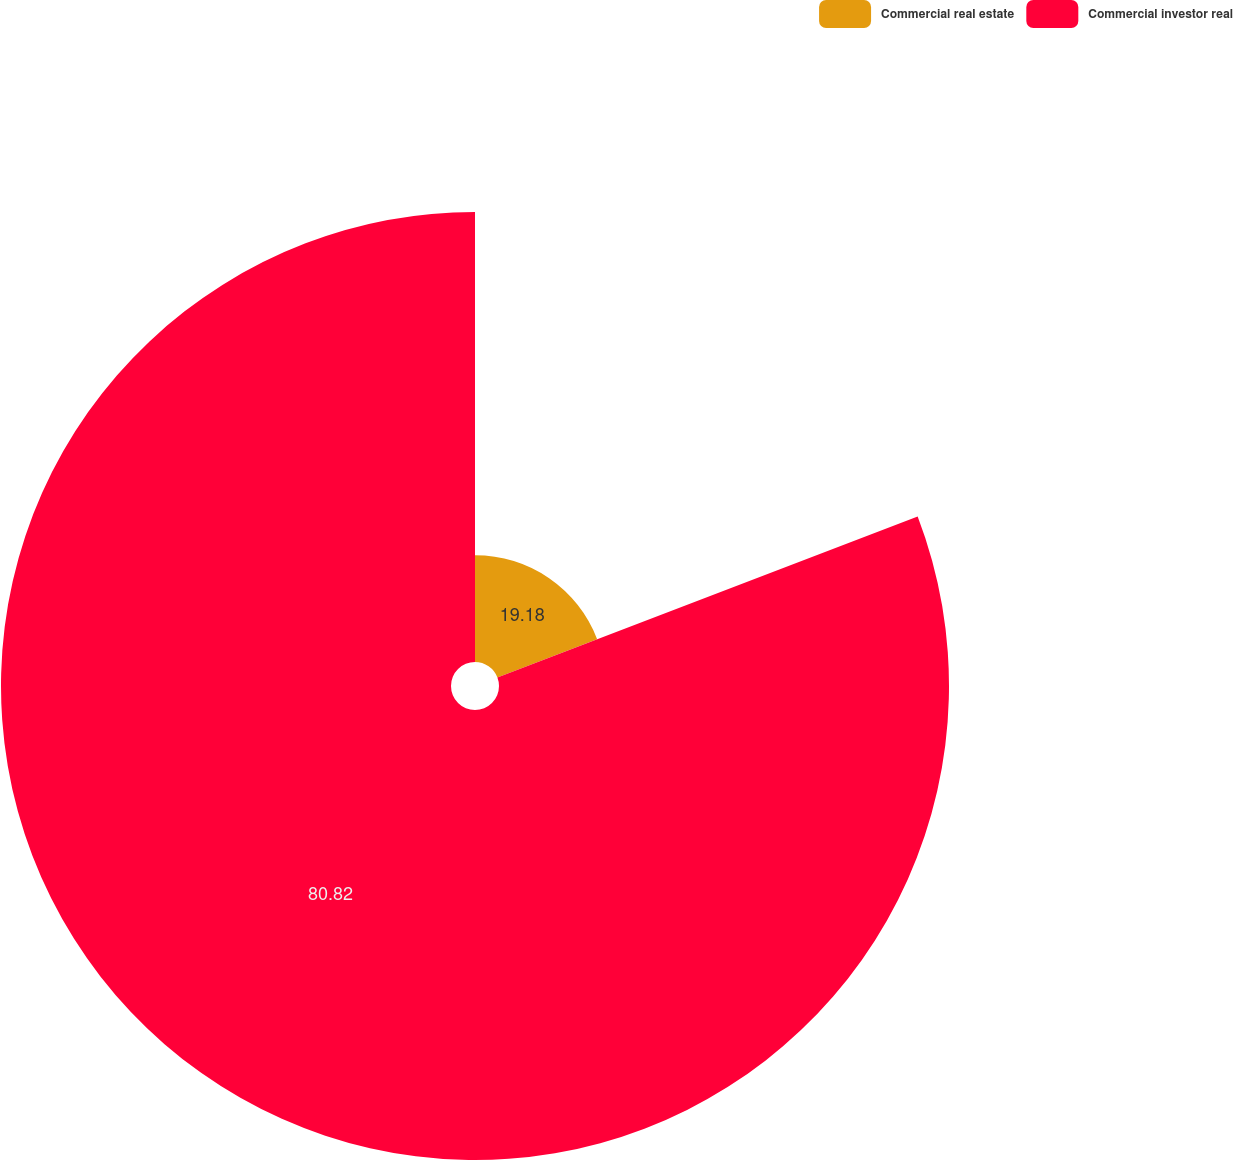Convert chart to OTSL. <chart><loc_0><loc_0><loc_500><loc_500><pie_chart><fcel>Commercial real estate<fcel>Commercial investor real<nl><fcel>19.18%<fcel>80.82%<nl></chart> 